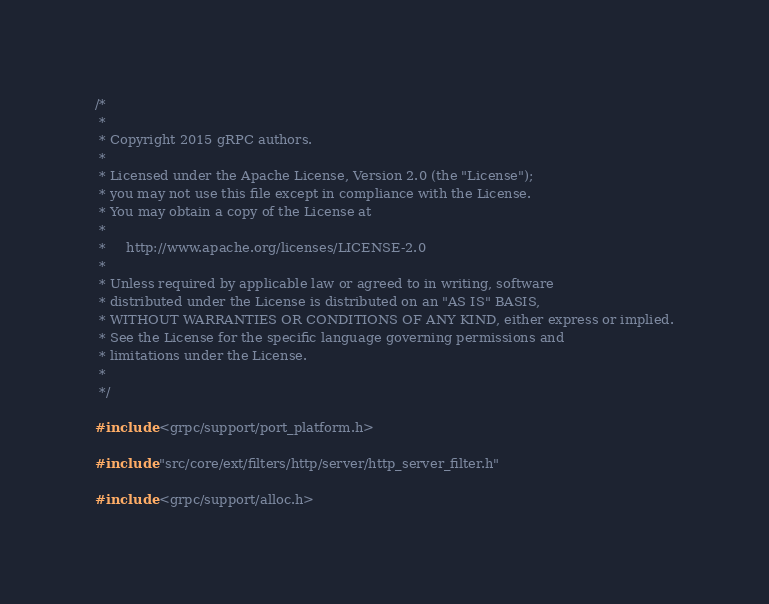Convert code to text. <code><loc_0><loc_0><loc_500><loc_500><_C++_>/*
 *
 * Copyright 2015 gRPC authors.
 *
 * Licensed under the Apache License, Version 2.0 (the "License");
 * you may not use this file except in compliance with the License.
 * You may obtain a copy of the License at
 *
 *     http://www.apache.org/licenses/LICENSE-2.0
 *
 * Unless required by applicable law or agreed to in writing, software
 * distributed under the License is distributed on an "AS IS" BASIS,
 * WITHOUT WARRANTIES OR CONDITIONS OF ANY KIND, either express or implied.
 * See the License for the specific language governing permissions and
 * limitations under the License.
 *
 */

#include <grpc/support/port_platform.h>

#include "src/core/ext/filters/http/server/http_server_filter.h"

#include <grpc/support/alloc.h></code> 